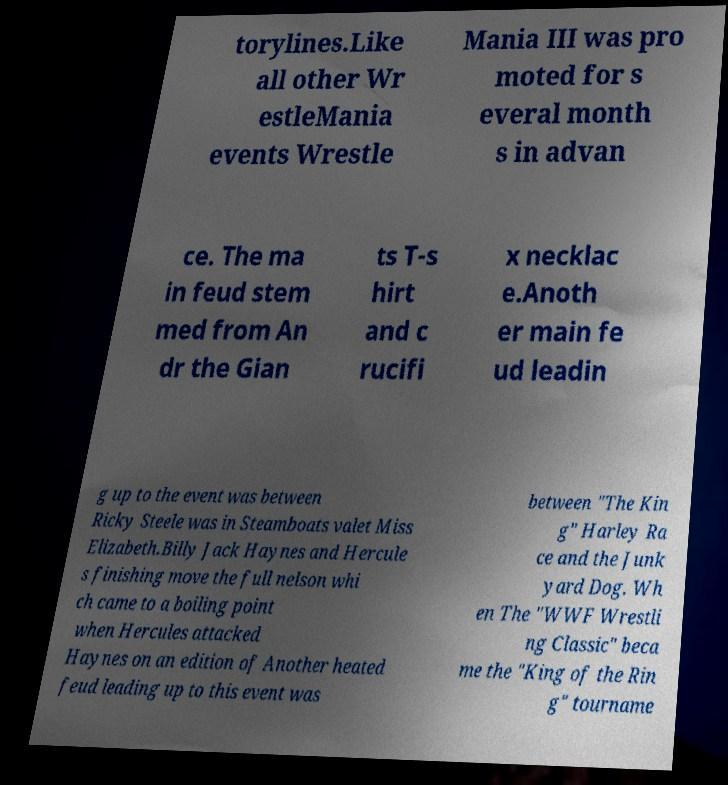Can you accurately transcribe the text from the provided image for me? torylines.Like all other Wr estleMania events Wrestle Mania III was pro moted for s everal month s in advan ce. The ma in feud stem med from An dr the Gian ts T-s hirt and c rucifi x necklac e.Anoth er main fe ud leadin g up to the event was between Ricky Steele was in Steamboats valet Miss Elizabeth.Billy Jack Haynes and Hercule s finishing move the full nelson whi ch came to a boiling point when Hercules attacked Haynes on an edition of Another heated feud leading up to this event was between "The Kin g" Harley Ra ce and the Junk yard Dog. Wh en The "WWF Wrestli ng Classic" beca me the "King of the Rin g" tourname 